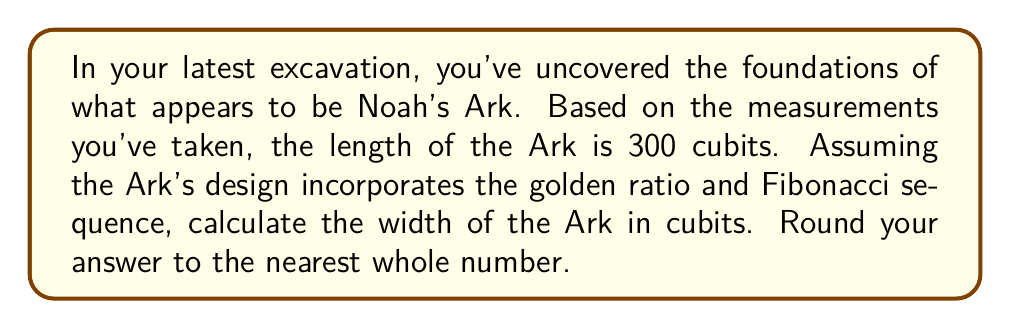Help me with this question. To solve this problem, we'll follow these steps:

1) The golden ratio, denoted by φ (phi), is approximately equal to 1.618034. It can be expressed as:

   $$φ = \frac{1 + \sqrt{5}}{2} ≈ 1.618034$$

2) In the Fibonacci sequence, the ratio of consecutive terms approaches the golden ratio as the sequence progresses. The sequence starts with 0, 1, and each subsequent number is the sum of the two preceding ones:

   0, 1, 1, 2, 3, 5, 8, 13, 21, 34, 55, 89, 144, ...

3) The 12th and 13th terms of the Fibonacci sequence are 144 and 233. Their ratio is very close to φ:

   $$\frac{233}{144} ≈ 1.618056$$

4) Using this ratio, we can set up an equation to find the width of the Ark:

   $$\frac{\text{length}}{\text{width}} = \frac{233}{144}$$

5) Substituting the known length of 300 cubits:

   $$\frac{300}{\text{width}} = \frac{233}{144}$$

6) Cross-multiply:

   $$300 * 144 = \text{width} * 233$$

7) Solve for width:

   $$\text{width} = \frac{300 * 144}{233} ≈ 185.4077 \text{ cubits}$$

8) Rounding to the nearest whole number:

   $$\text{width} ≈ 185 \text{ cubits}$$
Answer: 185 cubits 